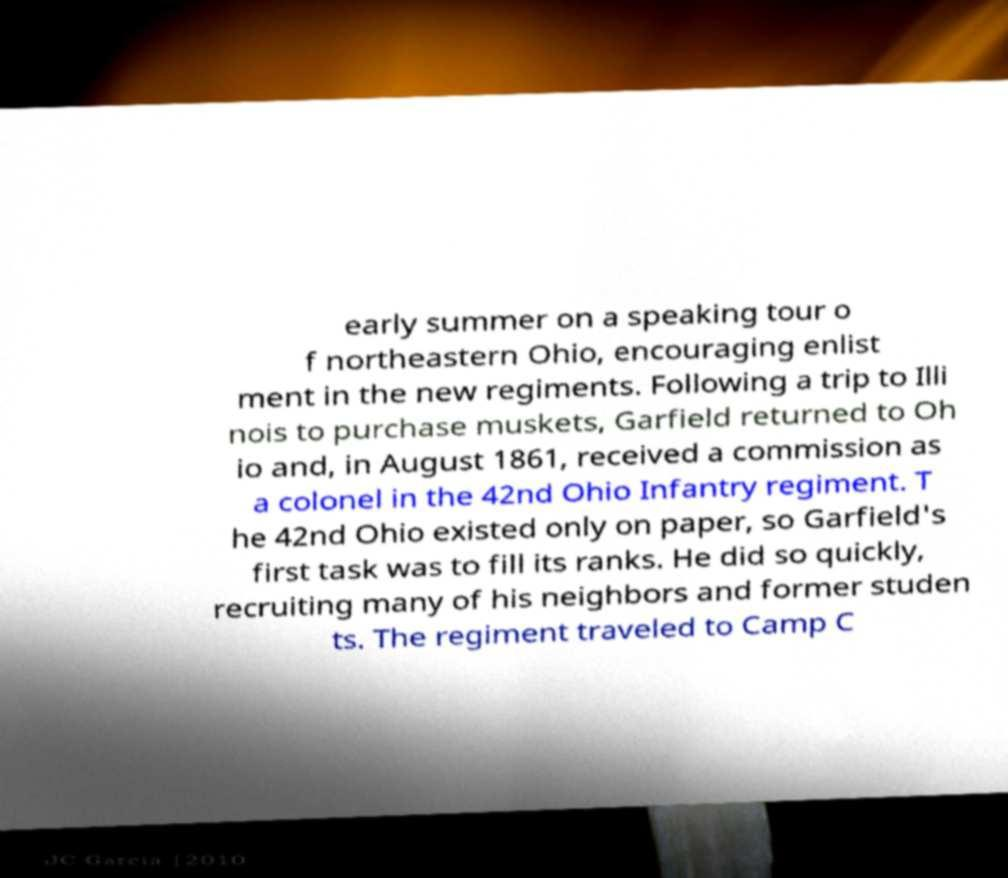Can you accurately transcribe the text from the provided image for me? early summer on a speaking tour o f northeastern Ohio, encouraging enlist ment in the new regiments. Following a trip to Illi nois to purchase muskets, Garfield returned to Oh io and, in August 1861, received a commission as a colonel in the 42nd Ohio Infantry regiment. T he 42nd Ohio existed only on paper, so Garfield's first task was to fill its ranks. He did so quickly, recruiting many of his neighbors and former studen ts. The regiment traveled to Camp C 